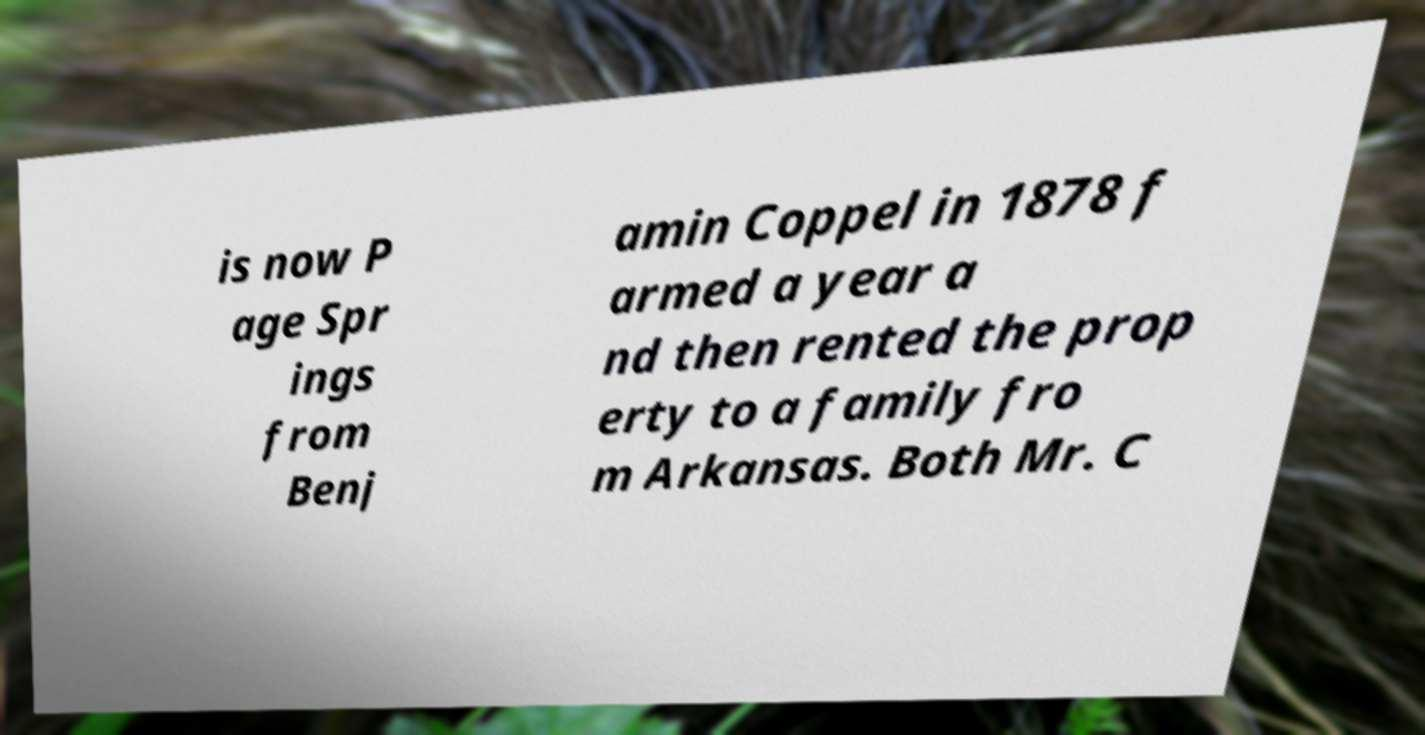I need the written content from this picture converted into text. Can you do that? is now P age Spr ings from Benj amin Coppel in 1878 f armed a year a nd then rented the prop erty to a family fro m Arkansas. Both Mr. C 